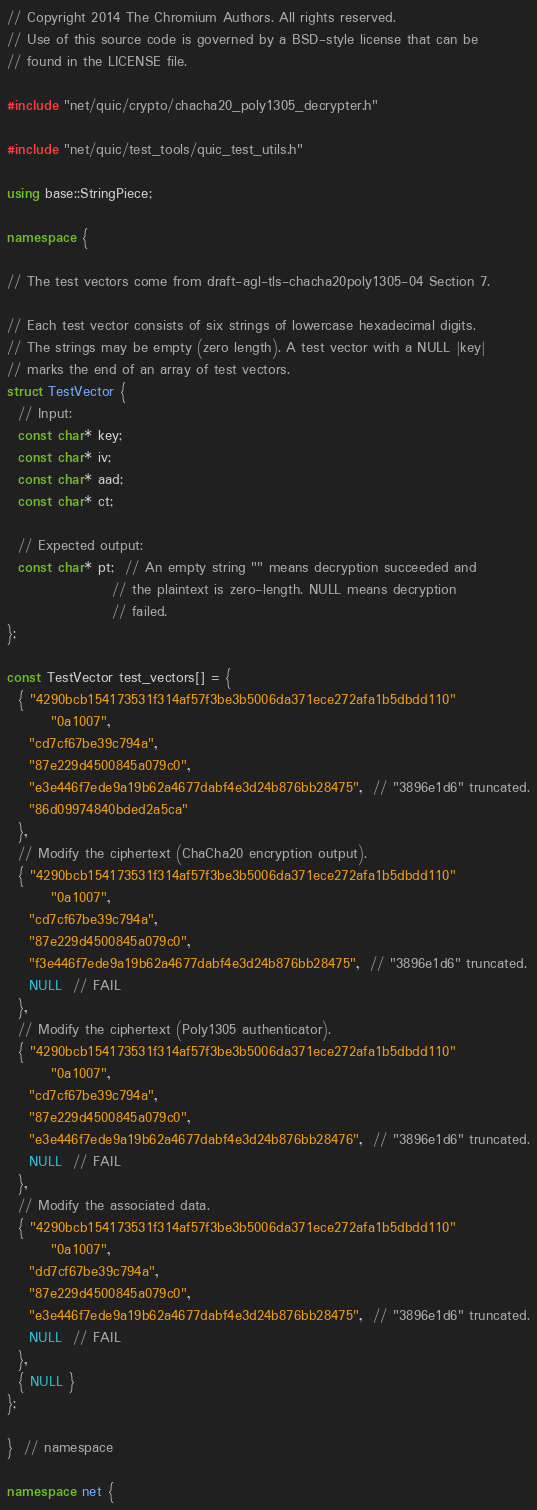<code> <loc_0><loc_0><loc_500><loc_500><_C++_>// Copyright 2014 The Chromium Authors. All rights reserved.
// Use of this source code is governed by a BSD-style license that can be
// found in the LICENSE file.

#include "net/quic/crypto/chacha20_poly1305_decrypter.h"

#include "net/quic/test_tools/quic_test_utils.h"

using base::StringPiece;

namespace {

// The test vectors come from draft-agl-tls-chacha20poly1305-04 Section 7.

// Each test vector consists of six strings of lowercase hexadecimal digits.
// The strings may be empty (zero length). A test vector with a NULL |key|
// marks the end of an array of test vectors.
struct TestVector {
  // Input:
  const char* key;
  const char* iv;
  const char* aad;
  const char* ct;

  // Expected output:
  const char* pt;  // An empty string "" means decryption succeeded and
                   // the plaintext is zero-length. NULL means decryption
                   // failed.
};

const TestVector test_vectors[] = {
  { "4290bcb154173531f314af57f3be3b5006da371ece272afa1b5dbdd110"
        "0a1007",
    "cd7cf67be39c794a",
    "87e229d4500845a079c0",
    "e3e446f7ede9a19b62a4677dabf4e3d24b876bb28475",  // "3896e1d6" truncated.
    "86d09974840bded2a5ca"
  },
  // Modify the ciphertext (ChaCha20 encryption output).
  { "4290bcb154173531f314af57f3be3b5006da371ece272afa1b5dbdd110"
        "0a1007",
    "cd7cf67be39c794a",
    "87e229d4500845a079c0",
    "f3e446f7ede9a19b62a4677dabf4e3d24b876bb28475",  // "3896e1d6" truncated.
    NULL  // FAIL
  },
  // Modify the ciphertext (Poly1305 authenticator).
  { "4290bcb154173531f314af57f3be3b5006da371ece272afa1b5dbdd110"
        "0a1007",
    "cd7cf67be39c794a",
    "87e229d4500845a079c0",
    "e3e446f7ede9a19b62a4677dabf4e3d24b876bb28476",  // "3896e1d6" truncated.
    NULL  // FAIL
  },
  // Modify the associated data.
  { "4290bcb154173531f314af57f3be3b5006da371ece272afa1b5dbdd110"
        "0a1007",
    "dd7cf67be39c794a",
    "87e229d4500845a079c0",
    "e3e446f7ede9a19b62a4677dabf4e3d24b876bb28475",  // "3896e1d6" truncated.
    NULL  // FAIL
  },
  { NULL }
};

}  // namespace

namespace net {</code> 